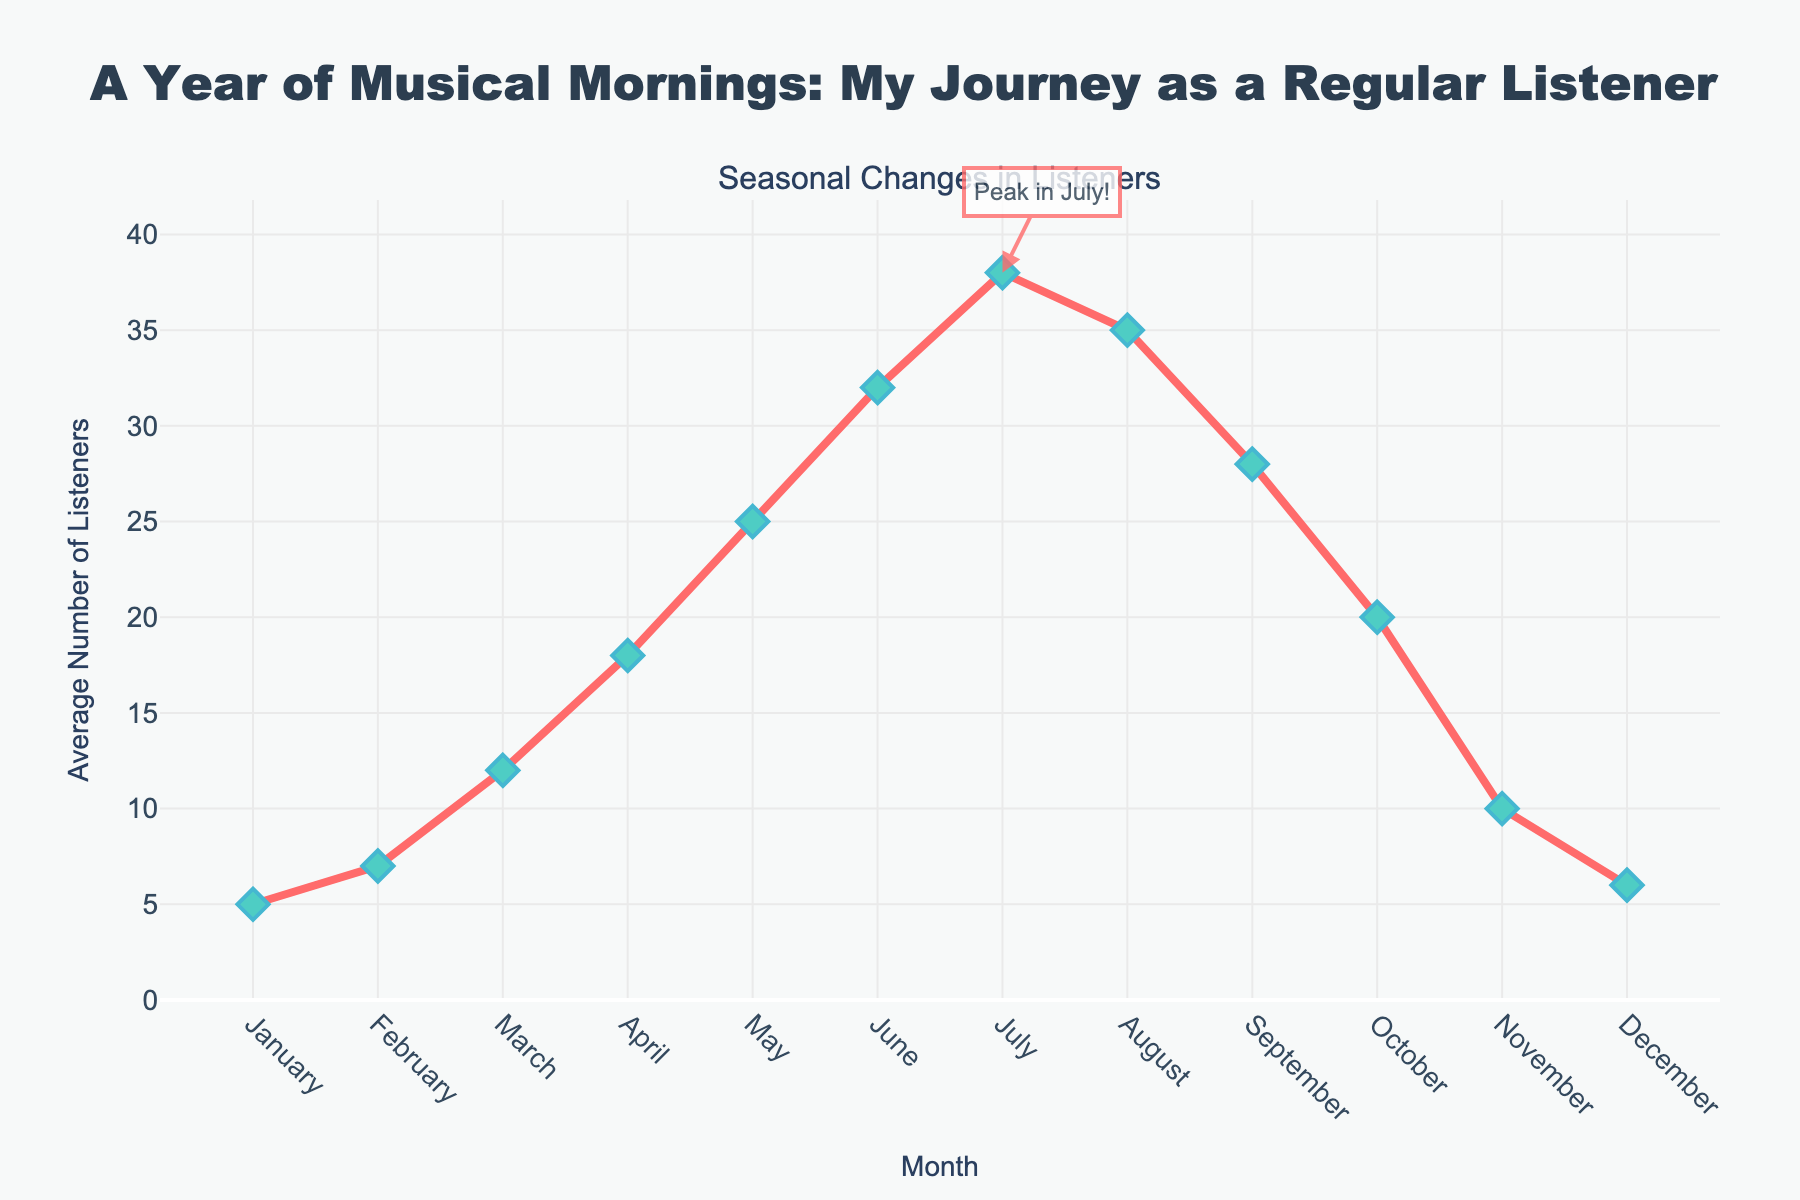Which month had the highest average number of listeners? Look for the data point with the highest value on the line chart. The peak average number of listeners is in July, with 38 listeners.
Answer: July How does the average number of listeners in January compare to December? Locate the data points for January and December. January has 5 listeners while December has 6.
Answer: December has 1 more listener than January What is the average number of listeners in spring (March, April, May)? Add the average listeners for March, April, and May, then divide by 3. (12 + 18 + 25) / 3 = 55 / 3 ≈ 18.33.
Answer: 18.33 During which month does the average number of listeners start to decrease after peaking in July? Identify the peak in July and observe the subsequent months. The average number of listeners starts to decrease in August.
Answer: August What is the difference in the average number of listeners between June and September? Locate the average listeners for June (32) and September (28) and find the difference. 32 - 28 = 4.
Answer: 4 In which months do the average number of listeners increase the most rapidly? Observe the steepest upward slope in the chart. Between February and March, the number of listeners increases rapidly from 7 to 12, and between April and May, it increases from 18 to 25.
Answer: March and May Calculate the total average number of listeners for the summer months (June, July, August). Sum the average listeners for June, July, and August. 32 + 38 + 35 = 105.
Answer: 105 Compare the average number of listeners in October to that in March. Which month has more? Locate October (20 listeners) and March (12 listeners) on the chart. October has more listeners than March.
Answer: October What visual cue indicates the peak month on the chart? The peak month is highlighted by an annotation "Peak in July!" with an arrow pointing to the data point for July.
Answer: Annotation and arrow By how much does the average number of listeners change from the beginning of spring (March) to the end of spring (May)? Subtract the average listeners in March from those in May. 25 - 12 = 13.
Answer: 13 